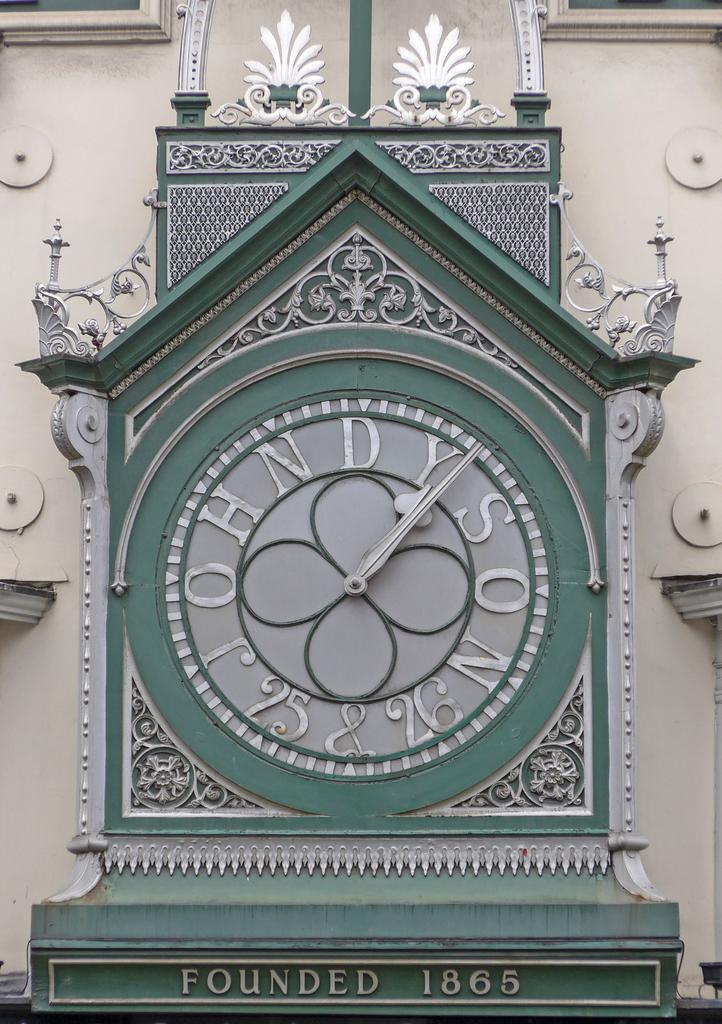<image>
Write a terse but informative summary of the picture. A large clock sits above a sign that says Founded 1865. 